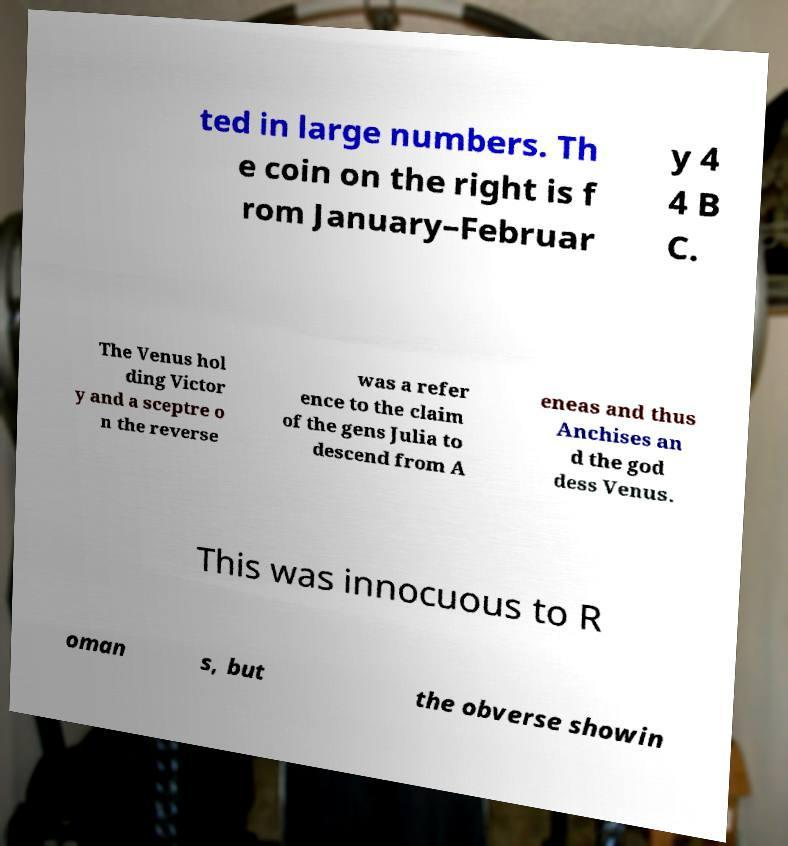Can you read and provide the text displayed in the image?This photo seems to have some interesting text. Can you extract and type it out for me? ted in large numbers. Th e coin on the right is f rom January–Februar y 4 4 B C. The Venus hol ding Victor y and a sceptre o n the reverse was a refer ence to the claim of the gens Julia to descend from A eneas and thus Anchises an d the god dess Venus. This was innocuous to R oman s, but the obverse showin 